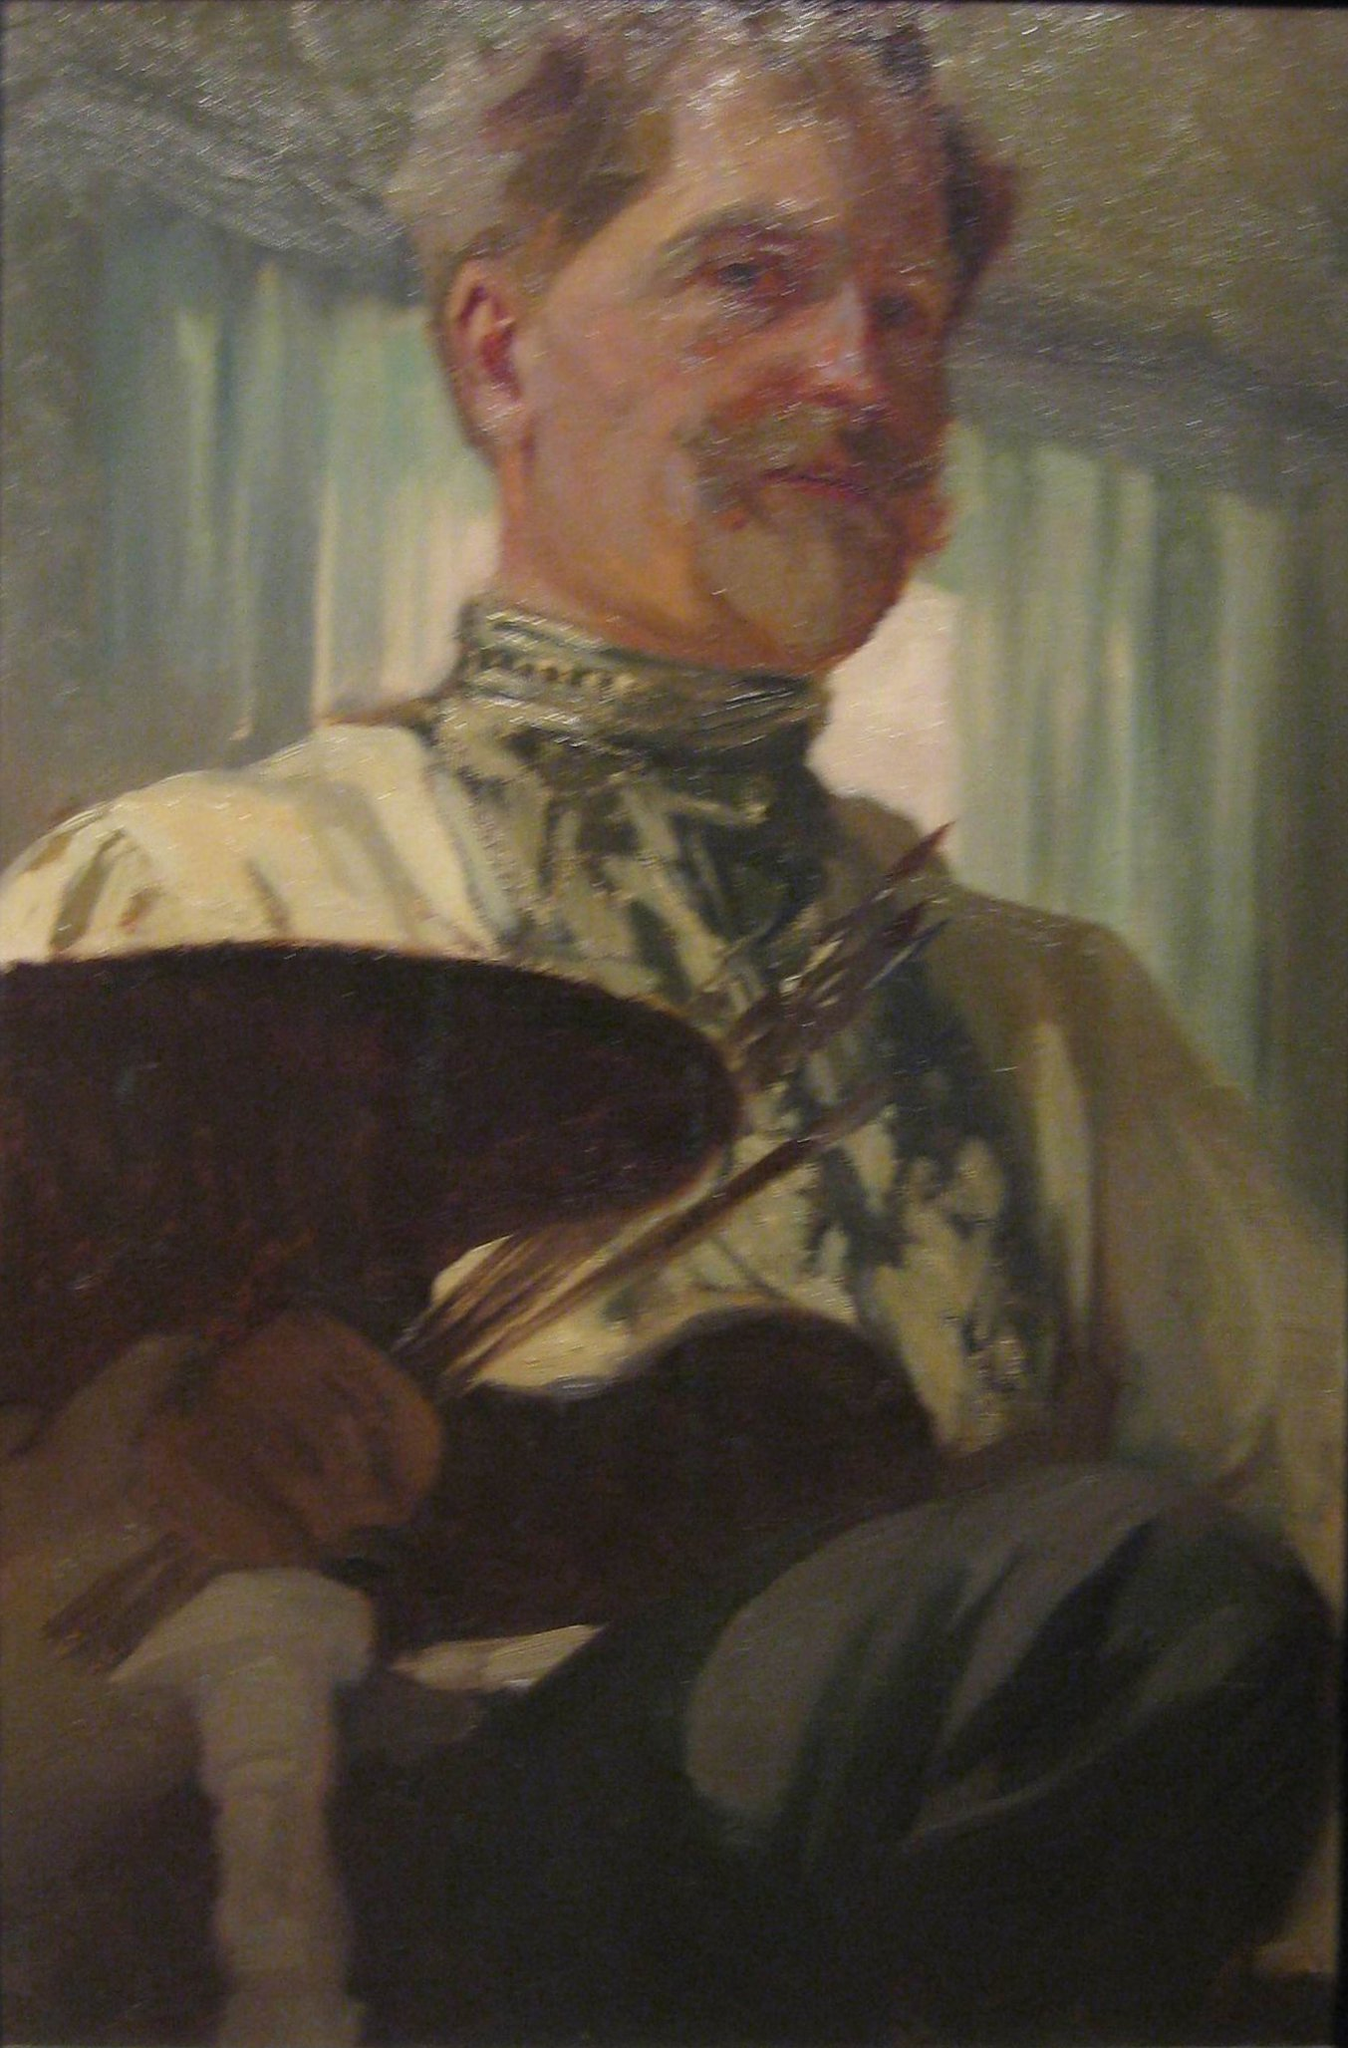Describe the emotion conveyed by the artist in the painting. The emotion conveyed by the artist in the painting appears to be one of tranquil concentration. His slightly upturned lips and softened gaze suggest a gentle, thoughtful demeanor. The light falling softly on his face and the serene backdrop of the greenish-blue curtain enhance this sense of calm and focus. This serene expression, combined with the detailed and loving way his attire and tools are depicted, implies a deep connection to his work. The overall atmosphere of the painting radiates a quiet pride and contentment, perhaps indicating the artist's satisfaction and sense of fulfillment from his creative endeavors. 